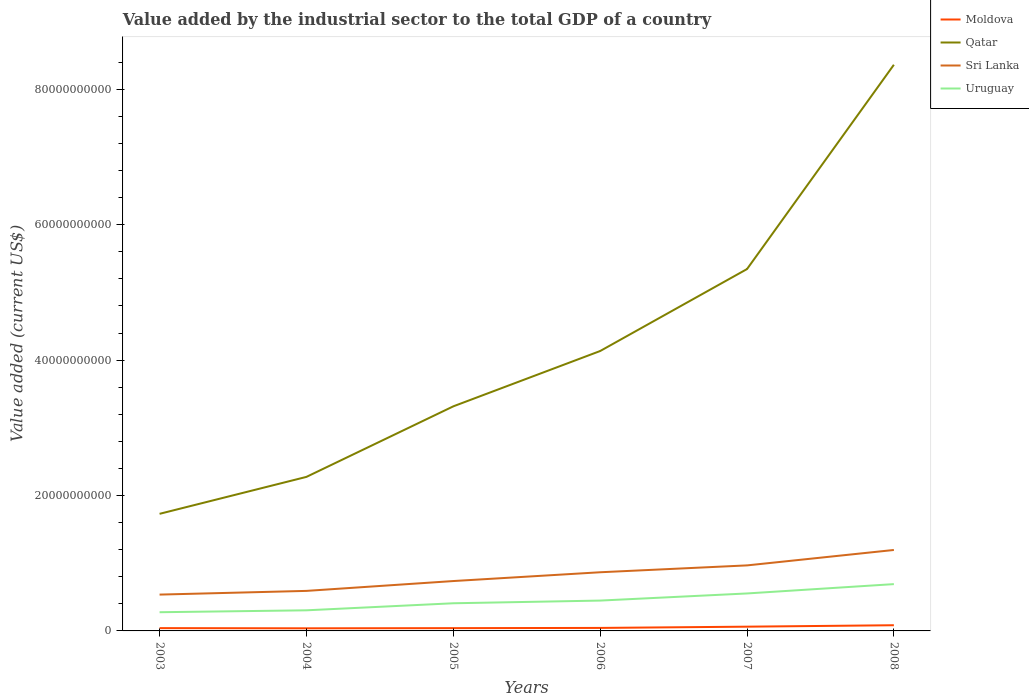How many different coloured lines are there?
Provide a succinct answer. 4. Across all years, what is the maximum value added by the industrial sector to the total GDP in Uruguay?
Your response must be concise. 2.76e+09. What is the total value added by the industrial sector to the total GDP in Qatar in the graph?
Keep it short and to the point. -1.59e+1. What is the difference between the highest and the second highest value added by the industrial sector to the total GDP in Moldova?
Your answer should be very brief. 4.55e+08. What is the difference between the highest and the lowest value added by the industrial sector to the total GDP in Sri Lanka?
Provide a succinct answer. 3. Is the value added by the industrial sector to the total GDP in Sri Lanka strictly greater than the value added by the industrial sector to the total GDP in Moldova over the years?
Your answer should be compact. No. How many years are there in the graph?
Provide a succinct answer. 6. Are the values on the major ticks of Y-axis written in scientific E-notation?
Your response must be concise. No. Does the graph contain grids?
Offer a terse response. No. How many legend labels are there?
Your answer should be compact. 4. How are the legend labels stacked?
Make the answer very short. Vertical. What is the title of the graph?
Offer a terse response. Value added by the industrial sector to the total GDP of a country. Does "France" appear as one of the legend labels in the graph?
Give a very brief answer. No. What is the label or title of the Y-axis?
Provide a short and direct response. Value added (current US$). What is the Value added (current US$) of Moldova in 2003?
Keep it short and to the point. 4.14e+08. What is the Value added (current US$) in Qatar in 2003?
Make the answer very short. 1.73e+1. What is the Value added (current US$) of Sri Lanka in 2003?
Ensure brevity in your answer.  5.37e+09. What is the Value added (current US$) of Uruguay in 2003?
Ensure brevity in your answer.  2.76e+09. What is the Value added (current US$) in Moldova in 2004?
Keep it short and to the point. 3.86e+08. What is the Value added (current US$) in Qatar in 2004?
Your answer should be compact. 2.28e+1. What is the Value added (current US$) of Sri Lanka in 2004?
Your answer should be very brief. 5.91e+09. What is the Value added (current US$) of Uruguay in 2004?
Offer a terse response. 3.04e+09. What is the Value added (current US$) of Moldova in 2005?
Make the answer very short. 4.10e+08. What is the Value added (current US$) in Qatar in 2005?
Make the answer very short. 3.32e+1. What is the Value added (current US$) in Sri Lanka in 2005?
Offer a very short reply. 7.37e+09. What is the Value added (current US$) in Uruguay in 2005?
Provide a short and direct response. 4.08e+09. What is the Value added (current US$) of Moldova in 2006?
Offer a very short reply. 4.43e+08. What is the Value added (current US$) of Qatar in 2006?
Your answer should be compact. 4.13e+1. What is the Value added (current US$) of Sri Lanka in 2006?
Your answer should be compact. 8.67e+09. What is the Value added (current US$) in Uruguay in 2006?
Your answer should be very brief. 4.48e+09. What is the Value added (current US$) of Moldova in 2007?
Offer a very short reply. 6.27e+08. What is the Value added (current US$) of Qatar in 2007?
Provide a short and direct response. 5.35e+1. What is the Value added (current US$) in Sri Lanka in 2007?
Give a very brief answer. 9.68e+09. What is the Value added (current US$) in Uruguay in 2007?
Make the answer very short. 5.54e+09. What is the Value added (current US$) of Moldova in 2008?
Keep it short and to the point. 8.41e+08. What is the Value added (current US$) of Qatar in 2008?
Make the answer very short. 8.36e+1. What is the Value added (current US$) in Sri Lanka in 2008?
Ensure brevity in your answer.  1.20e+1. What is the Value added (current US$) of Uruguay in 2008?
Your response must be concise. 6.91e+09. Across all years, what is the maximum Value added (current US$) of Moldova?
Offer a very short reply. 8.41e+08. Across all years, what is the maximum Value added (current US$) in Qatar?
Provide a succinct answer. 8.36e+1. Across all years, what is the maximum Value added (current US$) of Sri Lanka?
Keep it short and to the point. 1.20e+1. Across all years, what is the maximum Value added (current US$) of Uruguay?
Offer a very short reply. 6.91e+09. Across all years, what is the minimum Value added (current US$) of Moldova?
Provide a succinct answer. 3.86e+08. Across all years, what is the minimum Value added (current US$) of Qatar?
Your answer should be compact. 1.73e+1. Across all years, what is the minimum Value added (current US$) in Sri Lanka?
Keep it short and to the point. 5.37e+09. Across all years, what is the minimum Value added (current US$) of Uruguay?
Make the answer very short. 2.76e+09. What is the total Value added (current US$) in Moldova in the graph?
Give a very brief answer. 3.12e+09. What is the total Value added (current US$) in Qatar in the graph?
Your answer should be very brief. 2.52e+11. What is the total Value added (current US$) of Sri Lanka in the graph?
Offer a very short reply. 4.90e+1. What is the total Value added (current US$) of Uruguay in the graph?
Your answer should be compact. 2.68e+1. What is the difference between the Value added (current US$) of Moldova in 2003 and that in 2004?
Keep it short and to the point. 2.80e+07. What is the difference between the Value added (current US$) of Qatar in 2003 and that in 2004?
Give a very brief answer. -5.46e+09. What is the difference between the Value added (current US$) of Sri Lanka in 2003 and that in 2004?
Your answer should be compact. -5.46e+08. What is the difference between the Value added (current US$) of Uruguay in 2003 and that in 2004?
Your response must be concise. -2.83e+08. What is the difference between the Value added (current US$) in Moldova in 2003 and that in 2005?
Your answer should be compact. 3.86e+06. What is the difference between the Value added (current US$) of Qatar in 2003 and that in 2005?
Keep it short and to the point. -1.59e+1. What is the difference between the Value added (current US$) in Sri Lanka in 2003 and that in 2005?
Ensure brevity in your answer.  -2.00e+09. What is the difference between the Value added (current US$) in Uruguay in 2003 and that in 2005?
Ensure brevity in your answer.  -1.32e+09. What is the difference between the Value added (current US$) in Moldova in 2003 and that in 2006?
Your answer should be compact. -2.97e+07. What is the difference between the Value added (current US$) in Qatar in 2003 and that in 2006?
Give a very brief answer. -2.40e+1. What is the difference between the Value added (current US$) of Sri Lanka in 2003 and that in 2006?
Offer a very short reply. -3.30e+09. What is the difference between the Value added (current US$) of Uruguay in 2003 and that in 2006?
Provide a succinct answer. -1.72e+09. What is the difference between the Value added (current US$) in Moldova in 2003 and that in 2007?
Offer a terse response. -2.14e+08. What is the difference between the Value added (current US$) of Qatar in 2003 and that in 2007?
Provide a succinct answer. -3.62e+1. What is the difference between the Value added (current US$) in Sri Lanka in 2003 and that in 2007?
Keep it short and to the point. -4.31e+09. What is the difference between the Value added (current US$) of Uruguay in 2003 and that in 2007?
Offer a very short reply. -2.77e+09. What is the difference between the Value added (current US$) in Moldova in 2003 and that in 2008?
Offer a very short reply. -4.27e+08. What is the difference between the Value added (current US$) in Qatar in 2003 and that in 2008?
Keep it short and to the point. -6.63e+1. What is the difference between the Value added (current US$) of Sri Lanka in 2003 and that in 2008?
Your response must be concise. -6.59e+09. What is the difference between the Value added (current US$) in Uruguay in 2003 and that in 2008?
Make the answer very short. -4.15e+09. What is the difference between the Value added (current US$) of Moldova in 2004 and that in 2005?
Provide a short and direct response. -2.41e+07. What is the difference between the Value added (current US$) in Qatar in 2004 and that in 2005?
Make the answer very short. -1.04e+1. What is the difference between the Value added (current US$) of Sri Lanka in 2004 and that in 2005?
Provide a short and direct response. -1.45e+09. What is the difference between the Value added (current US$) of Uruguay in 2004 and that in 2005?
Your response must be concise. -1.04e+09. What is the difference between the Value added (current US$) in Moldova in 2004 and that in 2006?
Your response must be concise. -5.77e+07. What is the difference between the Value added (current US$) of Qatar in 2004 and that in 2006?
Offer a very short reply. -1.86e+1. What is the difference between the Value added (current US$) of Sri Lanka in 2004 and that in 2006?
Your answer should be compact. -2.75e+09. What is the difference between the Value added (current US$) in Uruguay in 2004 and that in 2006?
Provide a short and direct response. -1.44e+09. What is the difference between the Value added (current US$) in Moldova in 2004 and that in 2007?
Provide a short and direct response. -2.42e+08. What is the difference between the Value added (current US$) of Qatar in 2004 and that in 2007?
Provide a short and direct response. -3.07e+1. What is the difference between the Value added (current US$) in Sri Lanka in 2004 and that in 2007?
Make the answer very short. -3.77e+09. What is the difference between the Value added (current US$) in Uruguay in 2004 and that in 2007?
Provide a short and direct response. -2.49e+09. What is the difference between the Value added (current US$) in Moldova in 2004 and that in 2008?
Give a very brief answer. -4.55e+08. What is the difference between the Value added (current US$) in Qatar in 2004 and that in 2008?
Make the answer very short. -6.09e+1. What is the difference between the Value added (current US$) of Sri Lanka in 2004 and that in 2008?
Make the answer very short. -6.04e+09. What is the difference between the Value added (current US$) in Uruguay in 2004 and that in 2008?
Your answer should be compact. -3.87e+09. What is the difference between the Value added (current US$) in Moldova in 2005 and that in 2006?
Make the answer very short. -3.36e+07. What is the difference between the Value added (current US$) in Qatar in 2005 and that in 2006?
Your response must be concise. -8.17e+09. What is the difference between the Value added (current US$) of Sri Lanka in 2005 and that in 2006?
Provide a succinct answer. -1.30e+09. What is the difference between the Value added (current US$) in Uruguay in 2005 and that in 2006?
Your answer should be compact. -3.98e+08. What is the difference between the Value added (current US$) in Moldova in 2005 and that in 2007?
Keep it short and to the point. -2.17e+08. What is the difference between the Value added (current US$) in Qatar in 2005 and that in 2007?
Provide a short and direct response. -2.03e+1. What is the difference between the Value added (current US$) in Sri Lanka in 2005 and that in 2007?
Offer a very short reply. -2.31e+09. What is the difference between the Value added (current US$) of Uruguay in 2005 and that in 2007?
Give a very brief answer. -1.45e+09. What is the difference between the Value added (current US$) of Moldova in 2005 and that in 2008?
Provide a short and direct response. -4.31e+08. What is the difference between the Value added (current US$) in Qatar in 2005 and that in 2008?
Give a very brief answer. -5.05e+1. What is the difference between the Value added (current US$) of Sri Lanka in 2005 and that in 2008?
Provide a succinct answer. -4.59e+09. What is the difference between the Value added (current US$) of Uruguay in 2005 and that in 2008?
Your answer should be compact. -2.83e+09. What is the difference between the Value added (current US$) in Moldova in 2006 and that in 2007?
Offer a terse response. -1.84e+08. What is the difference between the Value added (current US$) of Qatar in 2006 and that in 2007?
Keep it short and to the point. -1.21e+1. What is the difference between the Value added (current US$) of Sri Lanka in 2006 and that in 2007?
Offer a very short reply. -1.01e+09. What is the difference between the Value added (current US$) in Uruguay in 2006 and that in 2007?
Provide a short and direct response. -1.05e+09. What is the difference between the Value added (current US$) of Moldova in 2006 and that in 2008?
Keep it short and to the point. -3.97e+08. What is the difference between the Value added (current US$) in Qatar in 2006 and that in 2008?
Your answer should be compact. -4.23e+1. What is the difference between the Value added (current US$) of Sri Lanka in 2006 and that in 2008?
Your answer should be very brief. -3.29e+09. What is the difference between the Value added (current US$) of Uruguay in 2006 and that in 2008?
Offer a very short reply. -2.43e+09. What is the difference between the Value added (current US$) in Moldova in 2007 and that in 2008?
Your answer should be very brief. -2.13e+08. What is the difference between the Value added (current US$) of Qatar in 2007 and that in 2008?
Make the answer very short. -3.02e+1. What is the difference between the Value added (current US$) of Sri Lanka in 2007 and that in 2008?
Offer a very short reply. -2.28e+09. What is the difference between the Value added (current US$) of Uruguay in 2007 and that in 2008?
Offer a very short reply. -1.38e+09. What is the difference between the Value added (current US$) in Moldova in 2003 and the Value added (current US$) in Qatar in 2004?
Make the answer very short. -2.23e+1. What is the difference between the Value added (current US$) of Moldova in 2003 and the Value added (current US$) of Sri Lanka in 2004?
Offer a very short reply. -5.50e+09. What is the difference between the Value added (current US$) of Moldova in 2003 and the Value added (current US$) of Uruguay in 2004?
Ensure brevity in your answer.  -2.63e+09. What is the difference between the Value added (current US$) of Qatar in 2003 and the Value added (current US$) of Sri Lanka in 2004?
Ensure brevity in your answer.  1.14e+1. What is the difference between the Value added (current US$) of Qatar in 2003 and the Value added (current US$) of Uruguay in 2004?
Your answer should be compact. 1.43e+1. What is the difference between the Value added (current US$) in Sri Lanka in 2003 and the Value added (current US$) in Uruguay in 2004?
Provide a succinct answer. 2.32e+09. What is the difference between the Value added (current US$) in Moldova in 2003 and the Value added (current US$) in Qatar in 2005?
Your answer should be very brief. -3.28e+1. What is the difference between the Value added (current US$) of Moldova in 2003 and the Value added (current US$) of Sri Lanka in 2005?
Your response must be concise. -6.95e+09. What is the difference between the Value added (current US$) of Moldova in 2003 and the Value added (current US$) of Uruguay in 2005?
Make the answer very short. -3.67e+09. What is the difference between the Value added (current US$) in Qatar in 2003 and the Value added (current US$) in Sri Lanka in 2005?
Your response must be concise. 9.93e+09. What is the difference between the Value added (current US$) in Qatar in 2003 and the Value added (current US$) in Uruguay in 2005?
Ensure brevity in your answer.  1.32e+1. What is the difference between the Value added (current US$) in Sri Lanka in 2003 and the Value added (current US$) in Uruguay in 2005?
Offer a terse response. 1.28e+09. What is the difference between the Value added (current US$) in Moldova in 2003 and the Value added (current US$) in Qatar in 2006?
Give a very brief answer. -4.09e+1. What is the difference between the Value added (current US$) in Moldova in 2003 and the Value added (current US$) in Sri Lanka in 2006?
Ensure brevity in your answer.  -8.25e+09. What is the difference between the Value added (current US$) of Moldova in 2003 and the Value added (current US$) of Uruguay in 2006?
Give a very brief answer. -4.07e+09. What is the difference between the Value added (current US$) of Qatar in 2003 and the Value added (current US$) of Sri Lanka in 2006?
Your answer should be very brief. 8.63e+09. What is the difference between the Value added (current US$) in Qatar in 2003 and the Value added (current US$) in Uruguay in 2006?
Your answer should be compact. 1.28e+1. What is the difference between the Value added (current US$) in Sri Lanka in 2003 and the Value added (current US$) in Uruguay in 2006?
Your answer should be very brief. 8.84e+08. What is the difference between the Value added (current US$) in Moldova in 2003 and the Value added (current US$) in Qatar in 2007?
Your response must be concise. -5.30e+1. What is the difference between the Value added (current US$) of Moldova in 2003 and the Value added (current US$) of Sri Lanka in 2007?
Your response must be concise. -9.27e+09. What is the difference between the Value added (current US$) in Moldova in 2003 and the Value added (current US$) in Uruguay in 2007?
Make the answer very short. -5.12e+09. What is the difference between the Value added (current US$) in Qatar in 2003 and the Value added (current US$) in Sri Lanka in 2007?
Make the answer very short. 7.62e+09. What is the difference between the Value added (current US$) in Qatar in 2003 and the Value added (current US$) in Uruguay in 2007?
Offer a very short reply. 1.18e+1. What is the difference between the Value added (current US$) in Sri Lanka in 2003 and the Value added (current US$) in Uruguay in 2007?
Make the answer very short. -1.68e+08. What is the difference between the Value added (current US$) in Moldova in 2003 and the Value added (current US$) in Qatar in 2008?
Your answer should be very brief. -8.32e+1. What is the difference between the Value added (current US$) of Moldova in 2003 and the Value added (current US$) of Sri Lanka in 2008?
Your response must be concise. -1.15e+1. What is the difference between the Value added (current US$) in Moldova in 2003 and the Value added (current US$) in Uruguay in 2008?
Provide a succinct answer. -6.50e+09. What is the difference between the Value added (current US$) in Qatar in 2003 and the Value added (current US$) in Sri Lanka in 2008?
Provide a short and direct response. 5.34e+09. What is the difference between the Value added (current US$) in Qatar in 2003 and the Value added (current US$) in Uruguay in 2008?
Ensure brevity in your answer.  1.04e+1. What is the difference between the Value added (current US$) in Sri Lanka in 2003 and the Value added (current US$) in Uruguay in 2008?
Provide a short and direct response. -1.55e+09. What is the difference between the Value added (current US$) in Moldova in 2004 and the Value added (current US$) in Qatar in 2005?
Your response must be concise. -3.28e+1. What is the difference between the Value added (current US$) in Moldova in 2004 and the Value added (current US$) in Sri Lanka in 2005?
Provide a succinct answer. -6.98e+09. What is the difference between the Value added (current US$) in Moldova in 2004 and the Value added (current US$) in Uruguay in 2005?
Your answer should be very brief. -3.70e+09. What is the difference between the Value added (current US$) of Qatar in 2004 and the Value added (current US$) of Sri Lanka in 2005?
Offer a very short reply. 1.54e+1. What is the difference between the Value added (current US$) of Qatar in 2004 and the Value added (current US$) of Uruguay in 2005?
Give a very brief answer. 1.87e+1. What is the difference between the Value added (current US$) in Sri Lanka in 2004 and the Value added (current US$) in Uruguay in 2005?
Your response must be concise. 1.83e+09. What is the difference between the Value added (current US$) of Moldova in 2004 and the Value added (current US$) of Qatar in 2006?
Offer a very short reply. -4.10e+1. What is the difference between the Value added (current US$) of Moldova in 2004 and the Value added (current US$) of Sri Lanka in 2006?
Offer a terse response. -8.28e+09. What is the difference between the Value added (current US$) of Moldova in 2004 and the Value added (current US$) of Uruguay in 2006?
Offer a terse response. -4.10e+09. What is the difference between the Value added (current US$) of Qatar in 2004 and the Value added (current US$) of Sri Lanka in 2006?
Offer a very short reply. 1.41e+1. What is the difference between the Value added (current US$) of Qatar in 2004 and the Value added (current US$) of Uruguay in 2006?
Give a very brief answer. 1.83e+1. What is the difference between the Value added (current US$) of Sri Lanka in 2004 and the Value added (current US$) of Uruguay in 2006?
Offer a very short reply. 1.43e+09. What is the difference between the Value added (current US$) of Moldova in 2004 and the Value added (current US$) of Qatar in 2007?
Ensure brevity in your answer.  -5.31e+1. What is the difference between the Value added (current US$) in Moldova in 2004 and the Value added (current US$) in Sri Lanka in 2007?
Offer a terse response. -9.29e+09. What is the difference between the Value added (current US$) of Moldova in 2004 and the Value added (current US$) of Uruguay in 2007?
Keep it short and to the point. -5.15e+09. What is the difference between the Value added (current US$) in Qatar in 2004 and the Value added (current US$) in Sri Lanka in 2007?
Make the answer very short. 1.31e+1. What is the difference between the Value added (current US$) in Qatar in 2004 and the Value added (current US$) in Uruguay in 2007?
Offer a terse response. 1.72e+1. What is the difference between the Value added (current US$) of Sri Lanka in 2004 and the Value added (current US$) of Uruguay in 2007?
Your answer should be very brief. 3.78e+08. What is the difference between the Value added (current US$) of Moldova in 2004 and the Value added (current US$) of Qatar in 2008?
Ensure brevity in your answer.  -8.32e+1. What is the difference between the Value added (current US$) of Moldova in 2004 and the Value added (current US$) of Sri Lanka in 2008?
Your response must be concise. -1.16e+1. What is the difference between the Value added (current US$) in Moldova in 2004 and the Value added (current US$) in Uruguay in 2008?
Offer a very short reply. -6.53e+09. What is the difference between the Value added (current US$) in Qatar in 2004 and the Value added (current US$) in Sri Lanka in 2008?
Your answer should be compact. 1.08e+1. What is the difference between the Value added (current US$) of Qatar in 2004 and the Value added (current US$) of Uruguay in 2008?
Your answer should be very brief. 1.58e+1. What is the difference between the Value added (current US$) of Sri Lanka in 2004 and the Value added (current US$) of Uruguay in 2008?
Keep it short and to the point. -1.00e+09. What is the difference between the Value added (current US$) in Moldova in 2005 and the Value added (current US$) in Qatar in 2006?
Your response must be concise. -4.09e+1. What is the difference between the Value added (current US$) of Moldova in 2005 and the Value added (current US$) of Sri Lanka in 2006?
Your response must be concise. -8.26e+09. What is the difference between the Value added (current US$) of Moldova in 2005 and the Value added (current US$) of Uruguay in 2006?
Offer a very short reply. -4.07e+09. What is the difference between the Value added (current US$) in Qatar in 2005 and the Value added (current US$) in Sri Lanka in 2006?
Keep it short and to the point. 2.45e+1. What is the difference between the Value added (current US$) of Qatar in 2005 and the Value added (current US$) of Uruguay in 2006?
Your answer should be compact. 2.87e+1. What is the difference between the Value added (current US$) of Sri Lanka in 2005 and the Value added (current US$) of Uruguay in 2006?
Provide a short and direct response. 2.88e+09. What is the difference between the Value added (current US$) of Moldova in 2005 and the Value added (current US$) of Qatar in 2007?
Provide a succinct answer. -5.30e+1. What is the difference between the Value added (current US$) in Moldova in 2005 and the Value added (current US$) in Sri Lanka in 2007?
Ensure brevity in your answer.  -9.27e+09. What is the difference between the Value added (current US$) in Moldova in 2005 and the Value added (current US$) in Uruguay in 2007?
Provide a succinct answer. -5.13e+09. What is the difference between the Value added (current US$) of Qatar in 2005 and the Value added (current US$) of Sri Lanka in 2007?
Offer a very short reply. 2.35e+1. What is the difference between the Value added (current US$) of Qatar in 2005 and the Value added (current US$) of Uruguay in 2007?
Your answer should be compact. 2.76e+1. What is the difference between the Value added (current US$) in Sri Lanka in 2005 and the Value added (current US$) in Uruguay in 2007?
Your answer should be compact. 1.83e+09. What is the difference between the Value added (current US$) of Moldova in 2005 and the Value added (current US$) of Qatar in 2008?
Your response must be concise. -8.32e+1. What is the difference between the Value added (current US$) of Moldova in 2005 and the Value added (current US$) of Sri Lanka in 2008?
Your answer should be very brief. -1.15e+1. What is the difference between the Value added (current US$) of Moldova in 2005 and the Value added (current US$) of Uruguay in 2008?
Ensure brevity in your answer.  -6.50e+09. What is the difference between the Value added (current US$) of Qatar in 2005 and the Value added (current US$) of Sri Lanka in 2008?
Give a very brief answer. 2.12e+1. What is the difference between the Value added (current US$) of Qatar in 2005 and the Value added (current US$) of Uruguay in 2008?
Your response must be concise. 2.63e+1. What is the difference between the Value added (current US$) in Sri Lanka in 2005 and the Value added (current US$) in Uruguay in 2008?
Offer a terse response. 4.54e+08. What is the difference between the Value added (current US$) in Moldova in 2006 and the Value added (current US$) in Qatar in 2007?
Your response must be concise. -5.30e+1. What is the difference between the Value added (current US$) in Moldova in 2006 and the Value added (current US$) in Sri Lanka in 2007?
Make the answer very short. -9.24e+09. What is the difference between the Value added (current US$) in Moldova in 2006 and the Value added (current US$) in Uruguay in 2007?
Make the answer very short. -5.09e+09. What is the difference between the Value added (current US$) in Qatar in 2006 and the Value added (current US$) in Sri Lanka in 2007?
Give a very brief answer. 3.17e+1. What is the difference between the Value added (current US$) in Qatar in 2006 and the Value added (current US$) in Uruguay in 2007?
Give a very brief answer. 3.58e+1. What is the difference between the Value added (current US$) of Sri Lanka in 2006 and the Value added (current US$) of Uruguay in 2007?
Your response must be concise. 3.13e+09. What is the difference between the Value added (current US$) in Moldova in 2006 and the Value added (current US$) in Qatar in 2008?
Your answer should be very brief. -8.32e+1. What is the difference between the Value added (current US$) in Moldova in 2006 and the Value added (current US$) in Sri Lanka in 2008?
Give a very brief answer. -1.15e+1. What is the difference between the Value added (current US$) in Moldova in 2006 and the Value added (current US$) in Uruguay in 2008?
Your answer should be very brief. -6.47e+09. What is the difference between the Value added (current US$) of Qatar in 2006 and the Value added (current US$) of Sri Lanka in 2008?
Provide a succinct answer. 2.94e+1. What is the difference between the Value added (current US$) of Qatar in 2006 and the Value added (current US$) of Uruguay in 2008?
Give a very brief answer. 3.44e+1. What is the difference between the Value added (current US$) of Sri Lanka in 2006 and the Value added (current US$) of Uruguay in 2008?
Provide a short and direct response. 1.75e+09. What is the difference between the Value added (current US$) of Moldova in 2007 and the Value added (current US$) of Qatar in 2008?
Keep it short and to the point. -8.30e+1. What is the difference between the Value added (current US$) of Moldova in 2007 and the Value added (current US$) of Sri Lanka in 2008?
Keep it short and to the point. -1.13e+1. What is the difference between the Value added (current US$) of Moldova in 2007 and the Value added (current US$) of Uruguay in 2008?
Your response must be concise. -6.29e+09. What is the difference between the Value added (current US$) of Qatar in 2007 and the Value added (current US$) of Sri Lanka in 2008?
Offer a very short reply. 4.15e+1. What is the difference between the Value added (current US$) in Qatar in 2007 and the Value added (current US$) in Uruguay in 2008?
Your answer should be compact. 4.65e+1. What is the difference between the Value added (current US$) in Sri Lanka in 2007 and the Value added (current US$) in Uruguay in 2008?
Provide a succinct answer. 2.77e+09. What is the average Value added (current US$) in Moldova per year?
Provide a short and direct response. 5.20e+08. What is the average Value added (current US$) in Qatar per year?
Your answer should be very brief. 4.19e+1. What is the average Value added (current US$) of Sri Lanka per year?
Provide a succinct answer. 8.16e+09. What is the average Value added (current US$) in Uruguay per year?
Keep it short and to the point. 4.47e+09. In the year 2003, what is the difference between the Value added (current US$) in Moldova and Value added (current US$) in Qatar?
Provide a short and direct response. -1.69e+1. In the year 2003, what is the difference between the Value added (current US$) in Moldova and Value added (current US$) in Sri Lanka?
Offer a terse response. -4.95e+09. In the year 2003, what is the difference between the Value added (current US$) in Moldova and Value added (current US$) in Uruguay?
Provide a succinct answer. -2.35e+09. In the year 2003, what is the difference between the Value added (current US$) in Qatar and Value added (current US$) in Sri Lanka?
Offer a very short reply. 1.19e+1. In the year 2003, what is the difference between the Value added (current US$) of Qatar and Value added (current US$) of Uruguay?
Keep it short and to the point. 1.45e+1. In the year 2003, what is the difference between the Value added (current US$) in Sri Lanka and Value added (current US$) in Uruguay?
Provide a succinct answer. 2.61e+09. In the year 2004, what is the difference between the Value added (current US$) in Moldova and Value added (current US$) in Qatar?
Keep it short and to the point. -2.24e+1. In the year 2004, what is the difference between the Value added (current US$) in Moldova and Value added (current US$) in Sri Lanka?
Offer a very short reply. -5.53e+09. In the year 2004, what is the difference between the Value added (current US$) of Moldova and Value added (current US$) of Uruguay?
Offer a terse response. -2.66e+09. In the year 2004, what is the difference between the Value added (current US$) of Qatar and Value added (current US$) of Sri Lanka?
Provide a succinct answer. 1.68e+1. In the year 2004, what is the difference between the Value added (current US$) in Qatar and Value added (current US$) in Uruguay?
Your answer should be compact. 1.97e+1. In the year 2004, what is the difference between the Value added (current US$) of Sri Lanka and Value added (current US$) of Uruguay?
Offer a very short reply. 2.87e+09. In the year 2005, what is the difference between the Value added (current US$) of Moldova and Value added (current US$) of Qatar?
Your response must be concise. -3.28e+1. In the year 2005, what is the difference between the Value added (current US$) of Moldova and Value added (current US$) of Sri Lanka?
Keep it short and to the point. -6.96e+09. In the year 2005, what is the difference between the Value added (current US$) of Moldova and Value added (current US$) of Uruguay?
Give a very brief answer. -3.67e+09. In the year 2005, what is the difference between the Value added (current US$) of Qatar and Value added (current US$) of Sri Lanka?
Your answer should be very brief. 2.58e+1. In the year 2005, what is the difference between the Value added (current US$) of Qatar and Value added (current US$) of Uruguay?
Your answer should be compact. 2.91e+1. In the year 2005, what is the difference between the Value added (current US$) in Sri Lanka and Value added (current US$) in Uruguay?
Give a very brief answer. 3.28e+09. In the year 2006, what is the difference between the Value added (current US$) of Moldova and Value added (current US$) of Qatar?
Offer a very short reply. -4.09e+1. In the year 2006, what is the difference between the Value added (current US$) in Moldova and Value added (current US$) in Sri Lanka?
Offer a terse response. -8.22e+09. In the year 2006, what is the difference between the Value added (current US$) in Moldova and Value added (current US$) in Uruguay?
Provide a short and direct response. -4.04e+09. In the year 2006, what is the difference between the Value added (current US$) in Qatar and Value added (current US$) in Sri Lanka?
Offer a very short reply. 3.27e+1. In the year 2006, what is the difference between the Value added (current US$) of Qatar and Value added (current US$) of Uruguay?
Give a very brief answer. 3.69e+1. In the year 2006, what is the difference between the Value added (current US$) of Sri Lanka and Value added (current US$) of Uruguay?
Offer a very short reply. 4.18e+09. In the year 2007, what is the difference between the Value added (current US$) of Moldova and Value added (current US$) of Qatar?
Make the answer very short. -5.28e+1. In the year 2007, what is the difference between the Value added (current US$) of Moldova and Value added (current US$) of Sri Lanka?
Give a very brief answer. -9.05e+09. In the year 2007, what is the difference between the Value added (current US$) in Moldova and Value added (current US$) in Uruguay?
Offer a very short reply. -4.91e+09. In the year 2007, what is the difference between the Value added (current US$) of Qatar and Value added (current US$) of Sri Lanka?
Your response must be concise. 4.38e+1. In the year 2007, what is the difference between the Value added (current US$) of Qatar and Value added (current US$) of Uruguay?
Offer a very short reply. 4.79e+1. In the year 2007, what is the difference between the Value added (current US$) in Sri Lanka and Value added (current US$) in Uruguay?
Your answer should be very brief. 4.14e+09. In the year 2008, what is the difference between the Value added (current US$) in Moldova and Value added (current US$) in Qatar?
Offer a terse response. -8.28e+1. In the year 2008, what is the difference between the Value added (current US$) in Moldova and Value added (current US$) in Sri Lanka?
Keep it short and to the point. -1.11e+1. In the year 2008, what is the difference between the Value added (current US$) of Moldova and Value added (current US$) of Uruguay?
Ensure brevity in your answer.  -6.07e+09. In the year 2008, what is the difference between the Value added (current US$) in Qatar and Value added (current US$) in Sri Lanka?
Offer a very short reply. 7.17e+1. In the year 2008, what is the difference between the Value added (current US$) of Qatar and Value added (current US$) of Uruguay?
Your response must be concise. 7.67e+1. In the year 2008, what is the difference between the Value added (current US$) in Sri Lanka and Value added (current US$) in Uruguay?
Ensure brevity in your answer.  5.04e+09. What is the ratio of the Value added (current US$) in Moldova in 2003 to that in 2004?
Keep it short and to the point. 1.07. What is the ratio of the Value added (current US$) in Qatar in 2003 to that in 2004?
Keep it short and to the point. 0.76. What is the ratio of the Value added (current US$) in Sri Lanka in 2003 to that in 2004?
Your answer should be compact. 0.91. What is the ratio of the Value added (current US$) in Uruguay in 2003 to that in 2004?
Keep it short and to the point. 0.91. What is the ratio of the Value added (current US$) in Moldova in 2003 to that in 2005?
Your answer should be compact. 1.01. What is the ratio of the Value added (current US$) of Qatar in 2003 to that in 2005?
Ensure brevity in your answer.  0.52. What is the ratio of the Value added (current US$) in Sri Lanka in 2003 to that in 2005?
Offer a terse response. 0.73. What is the ratio of the Value added (current US$) of Uruguay in 2003 to that in 2005?
Provide a short and direct response. 0.68. What is the ratio of the Value added (current US$) of Moldova in 2003 to that in 2006?
Give a very brief answer. 0.93. What is the ratio of the Value added (current US$) of Qatar in 2003 to that in 2006?
Give a very brief answer. 0.42. What is the ratio of the Value added (current US$) in Sri Lanka in 2003 to that in 2006?
Offer a very short reply. 0.62. What is the ratio of the Value added (current US$) of Uruguay in 2003 to that in 2006?
Ensure brevity in your answer.  0.62. What is the ratio of the Value added (current US$) in Moldova in 2003 to that in 2007?
Ensure brevity in your answer.  0.66. What is the ratio of the Value added (current US$) of Qatar in 2003 to that in 2007?
Your answer should be compact. 0.32. What is the ratio of the Value added (current US$) of Sri Lanka in 2003 to that in 2007?
Provide a succinct answer. 0.55. What is the ratio of the Value added (current US$) of Uruguay in 2003 to that in 2007?
Provide a succinct answer. 0.5. What is the ratio of the Value added (current US$) of Moldova in 2003 to that in 2008?
Your answer should be very brief. 0.49. What is the ratio of the Value added (current US$) in Qatar in 2003 to that in 2008?
Your response must be concise. 0.21. What is the ratio of the Value added (current US$) in Sri Lanka in 2003 to that in 2008?
Your answer should be very brief. 0.45. What is the ratio of the Value added (current US$) in Uruguay in 2003 to that in 2008?
Your answer should be very brief. 0.4. What is the ratio of the Value added (current US$) of Moldova in 2004 to that in 2005?
Provide a succinct answer. 0.94. What is the ratio of the Value added (current US$) in Qatar in 2004 to that in 2005?
Offer a terse response. 0.69. What is the ratio of the Value added (current US$) of Sri Lanka in 2004 to that in 2005?
Provide a succinct answer. 0.8. What is the ratio of the Value added (current US$) in Uruguay in 2004 to that in 2005?
Your answer should be very brief. 0.75. What is the ratio of the Value added (current US$) of Moldova in 2004 to that in 2006?
Provide a succinct answer. 0.87. What is the ratio of the Value added (current US$) of Qatar in 2004 to that in 2006?
Your answer should be compact. 0.55. What is the ratio of the Value added (current US$) of Sri Lanka in 2004 to that in 2006?
Keep it short and to the point. 0.68. What is the ratio of the Value added (current US$) of Uruguay in 2004 to that in 2006?
Your answer should be very brief. 0.68. What is the ratio of the Value added (current US$) in Moldova in 2004 to that in 2007?
Ensure brevity in your answer.  0.61. What is the ratio of the Value added (current US$) in Qatar in 2004 to that in 2007?
Your answer should be compact. 0.43. What is the ratio of the Value added (current US$) in Sri Lanka in 2004 to that in 2007?
Make the answer very short. 0.61. What is the ratio of the Value added (current US$) in Uruguay in 2004 to that in 2007?
Ensure brevity in your answer.  0.55. What is the ratio of the Value added (current US$) of Moldova in 2004 to that in 2008?
Make the answer very short. 0.46. What is the ratio of the Value added (current US$) of Qatar in 2004 to that in 2008?
Your answer should be very brief. 0.27. What is the ratio of the Value added (current US$) of Sri Lanka in 2004 to that in 2008?
Offer a very short reply. 0.49. What is the ratio of the Value added (current US$) of Uruguay in 2004 to that in 2008?
Keep it short and to the point. 0.44. What is the ratio of the Value added (current US$) in Moldova in 2005 to that in 2006?
Provide a short and direct response. 0.92. What is the ratio of the Value added (current US$) of Qatar in 2005 to that in 2006?
Ensure brevity in your answer.  0.8. What is the ratio of the Value added (current US$) in Sri Lanka in 2005 to that in 2006?
Provide a succinct answer. 0.85. What is the ratio of the Value added (current US$) of Uruguay in 2005 to that in 2006?
Make the answer very short. 0.91. What is the ratio of the Value added (current US$) of Moldova in 2005 to that in 2007?
Provide a succinct answer. 0.65. What is the ratio of the Value added (current US$) of Qatar in 2005 to that in 2007?
Keep it short and to the point. 0.62. What is the ratio of the Value added (current US$) of Sri Lanka in 2005 to that in 2007?
Your response must be concise. 0.76. What is the ratio of the Value added (current US$) in Uruguay in 2005 to that in 2007?
Give a very brief answer. 0.74. What is the ratio of the Value added (current US$) of Moldova in 2005 to that in 2008?
Your answer should be compact. 0.49. What is the ratio of the Value added (current US$) of Qatar in 2005 to that in 2008?
Offer a very short reply. 0.4. What is the ratio of the Value added (current US$) of Sri Lanka in 2005 to that in 2008?
Offer a very short reply. 0.62. What is the ratio of the Value added (current US$) of Uruguay in 2005 to that in 2008?
Offer a very short reply. 0.59. What is the ratio of the Value added (current US$) in Moldova in 2006 to that in 2007?
Keep it short and to the point. 0.71. What is the ratio of the Value added (current US$) of Qatar in 2006 to that in 2007?
Provide a succinct answer. 0.77. What is the ratio of the Value added (current US$) in Sri Lanka in 2006 to that in 2007?
Your answer should be compact. 0.9. What is the ratio of the Value added (current US$) in Uruguay in 2006 to that in 2007?
Offer a very short reply. 0.81. What is the ratio of the Value added (current US$) of Moldova in 2006 to that in 2008?
Keep it short and to the point. 0.53. What is the ratio of the Value added (current US$) in Qatar in 2006 to that in 2008?
Give a very brief answer. 0.49. What is the ratio of the Value added (current US$) in Sri Lanka in 2006 to that in 2008?
Give a very brief answer. 0.72. What is the ratio of the Value added (current US$) of Uruguay in 2006 to that in 2008?
Give a very brief answer. 0.65. What is the ratio of the Value added (current US$) of Moldova in 2007 to that in 2008?
Your answer should be compact. 0.75. What is the ratio of the Value added (current US$) of Qatar in 2007 to that in 2008?
Your answer should be compact. 0.64. What is the ratio of the Value added (current US$) in Sri Lanka in 2007 to that in 2008?
Provide a short and direct response. 0.81. What is the ratio of the Value added (current US$) in Uruguay in 2007 to that in 2008?
Make the answer very short. 0.8. What is the difference between the highest and the second highest Value added (current US$) in Moldova?
Ensure brevity in your answer.  2.13e+08. What is the difference between the highest and the second highest Value added (current US$) in Qatar?
Keep it short and to the point. 3.02e+1. What is the difference between the highest and the second highest Value added (current US$) of Sri Lanka?
Your response must be concise. 2.28e+09. What is the difference between the highest and the second highest Value added (current US$) of Uruguay?
Your answer should be compact. 1.38e+09. What is the difference between the highest and the lowest Value added (current US$) of Moldova?
Keep it short and to the point. 4.55e+08. What is the difference between the highest and the lowest Value added (current US$) in Qatar?
Make the answer very short. 6.63e+1. What is the difference between the highest and the lowest Value added (current US$) in Sri Lanka?
Your response must be concise. 6.59e+09. What is the difference between the highest and the lowest Value added (current US$) of Uruguay?
Your answer should be compact. 4.15e+09. 